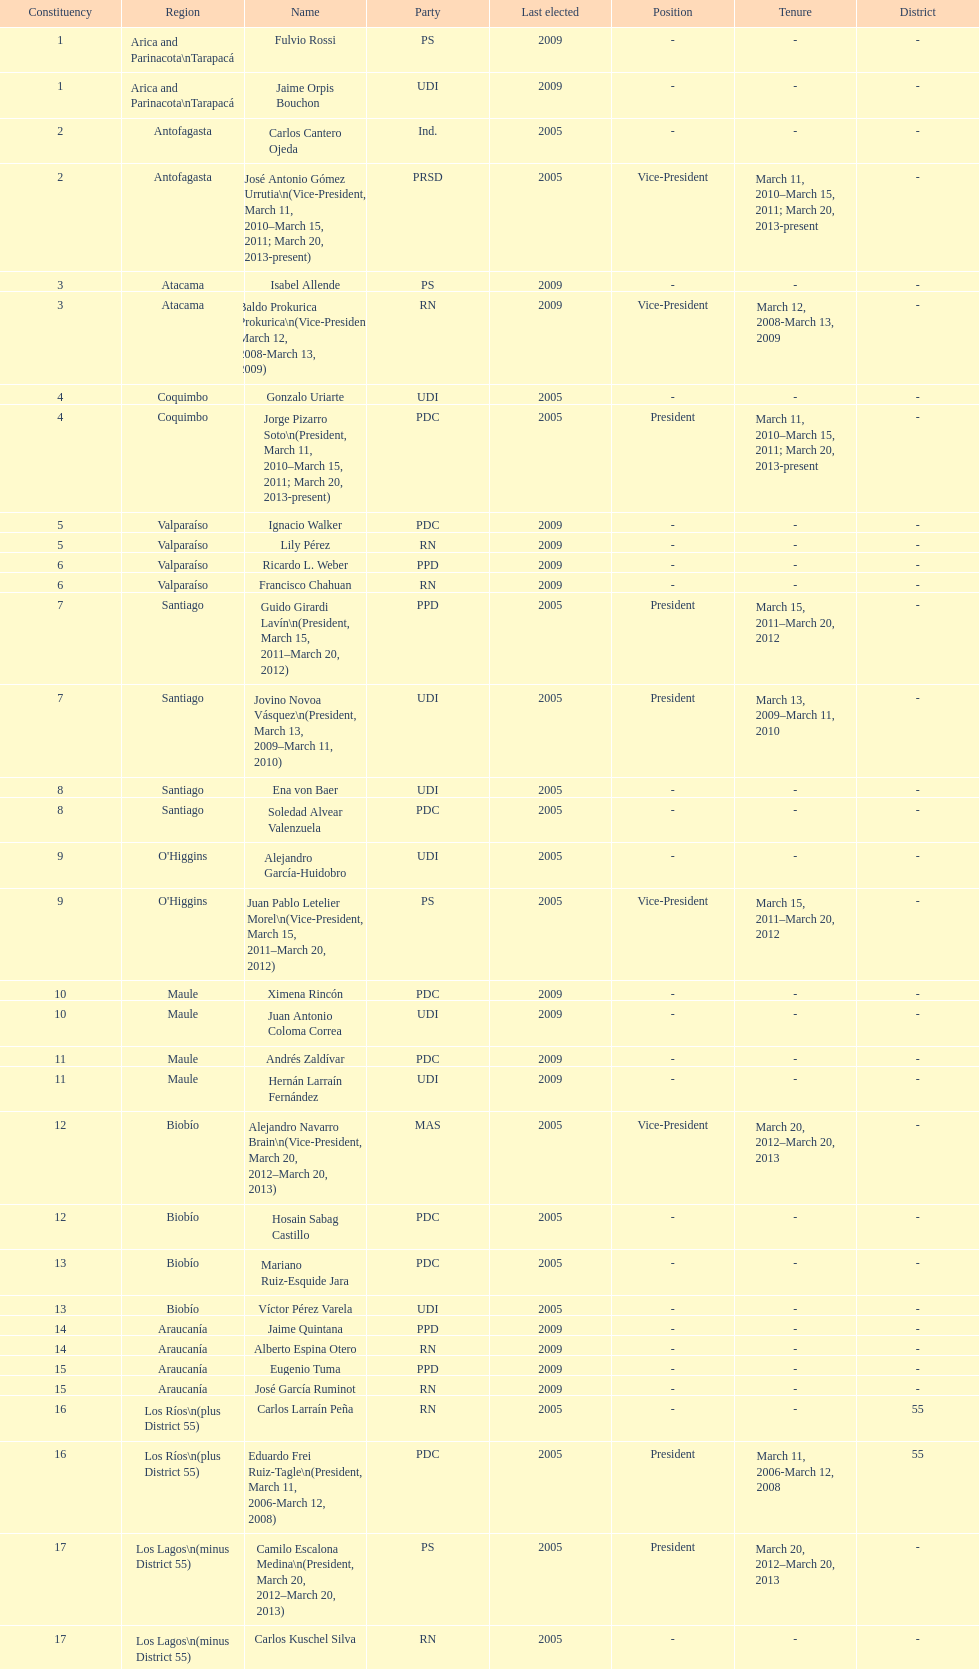Write the full table. {'header': ['Constituency', 'Region', 'Name', 'Party', 'Last elected', 'Position', 'Tenure', 'District'], 'rows': [['1', 'Arica and Parinacota\\nTarapacá', 'Fulvio Rossi', 'PS', '2009', '-', '-', '-'], ['1', 'Arica and Parinacota\\nTarapacá', 'Jaime Orpis Bouchon', 'UDI', '2009', '-', '-', '-'], ['2', 'Antofagasta', 'Carlos Cantero Ojeda', 'Ind.', '2005', '-', '-', '-'], ['2', 'Antofagasta', 'José Antonio Gómez Urrutia\\n(Vice-President, March 11, 2010–March 15, 2011; March 20, 2013-present)', 'PRSD', '2005', 'Vice-President', 'March 11, 2010–March 15, 2011; March 20, 2013-present', '-'], ['3', 'Atacama', 'Isabel Allende', 'PS', '2009', '-', '-', '-'], ['3', 'Atacama', 'Baldo Prokurica Prokurica\\n(Vice-President, March 12, 2008-March 13, 2009)', 'RN', '2009', 'Vice-President', 'March 12, 2008-March 13, 2009', '-'], ['4', 'Coquimbo', 'Gonzalo Uriarte', 'UDI', '2005', '-', '-', '-'], ['4', 'Coquimbo', 'Jorge Pizarro Soto\\n(President, March 11, 2010–March 15, 2011; March 20, 2013-present)', 'PDC', '2005', 'President', 'March 11, 2010–March 15, 2011; March 20, 2013-present', '-'], ['5', 'Valparaíso', 'Ignacio Walker', 'PDC', '2009', '-', '-', '-'], ['5', 'Valparaíso', 'Lily Pérez', 'RN', '2009', '-', '-', '-'], ['6', 'Valparaíso', 'Ricardo L. Weber', 'PPD', '2009', '-', '-', '-'], ['6', 'Valparaíso', 'Francisco Chahuan', 'RN', '2009', '-', '-', '-'], ['7', 'Santiago', 'Guido Girardi Lavín\\n(President, March 15, 2011–March 20, 2012)', 'PPD', '2005', 'President', 'March 15, 2011–March 20, 2012', '-'], ['7', 'Santiago', 'Jovino Novoa Vásquez\\n(President, March 13, 2009–March 11, 2010)', 'UDI', '2005', 'President', 'March 13, 2009–March 11, 2010', '-'], ['8', 'Santiago', 'Ena von Baer', 'UDI', '2005', '-', '-', '-'], ['8', 'Santiago', 'Soledad Alvear Valenzuela', 'PDC', '2005', '-', '-', '-'], ['9', "O'Higgins", 'Alejandro García-Huidobro', 'UDI', '2005', '-', '-', '-'], ['9', "O'Higgins", 'Juan Pablo Letelier Morel\\n(Vice-President, March 15, 2011–March 20, 2012)', 'PS', '2005', 'Vice-President', 'March 15, 2011–March 20, 2012', '-'], ['10', 'Maule', 'Ximena Rincón', 'PDC', '2009', '-', '-', '-'], ['10', 'Maule', 'Juan Antonio Coloma Correa', 'UDI', '2009', '-', '-', '-'], ['11', 'Maule', 'Andrés Zaldívar', 'PDC', '2009', '-', '-', '-'], ['11', 'Maule', 'Hernán Larraín Fernández', 'UDI', '2009', '-', '-', '-'], ['12', 'Biobío', 'Alejandro Navarro Brain\\n(Vice-President, March 20, 2012–March 20, 2013)', 'MAS', '2005', 'Vice-President', 'March 20, 2012–March 20, 2013', '-'], ['12', 'Biobío', 'Hosain Sabag Castillo', 'PDC', '2005', '-', '-', '-'], ['13', 'Biobío', 'Mariano Ruiz-Esquide Jara', 'PDC', '2005', '-', '-', '-'], ['13', 'Biobío', 'Víctor Pérez Varela', 'UDI', '2005', '-', '-', '-'], ['14', 'Araucanía', 'Jaime Quintana', 'PPD', '2009', '-', '-', '-'], ['14', 'Araucanía', 'Alberto Espina Otero', 'RN', '2009', '-', '-', '-'], ['15', 'Araucanía', 'Eugenio Tuma', 'PPD', '2009', '-', '-', '-'], ['15', 'Araucanía', 'José García Ruminot', 'RN', '2009', '-', '-', '-'], ['16', 'Los Ríos\\n(plus District 55)', 'Carlos Larraín Peña', 'RN', '2005', '-', '-', '55'], ['16', 'Los Ríos\\n(plus District 55)', 'Eduardo Frei Ruiz-Tagle\\n(President, March 11, 2006-March 12, 2008)', 'PDC', '2005', 'President', 'March 11, 2006-March 12, 2008', '55'], ['17', 'Los Lagos\\n(minus District 55)', 'Camilo Escalona Medina\\n(President, March 20, 2012–March 20, 2013)', 'PS', '2005', 'President', 'March 20, 2012–March 20, 2013', '-'], ['17', 'Los Lagos\\n(minus District 55)', 'Carlos Kuschel Silva', 'RN', '2005', '-', '-', '-'], ['18', 'Aisén', 'Patricio Walker', 'PDC', '2009', '-', '-', '-'], ['18', 'Aisén', 'Antonio Horvath Kiss', 'RN', '2001', '-', '-', '-'], ['19', 'Magallanes', 'Carlos Bianchi Chelech\\n(Vice-President, March 13, 2009–March 11, 2010)', 'Ind.', '2005', 'Vice-President', 'March 13, 2009–March 11, 2010', '-'], ['19', 'Magallanes', 'Pedro Muñoz Aburto', 'PS', '2005', '-', '-', '-']]} What is the first name on the table? Fulvio Rossi. 